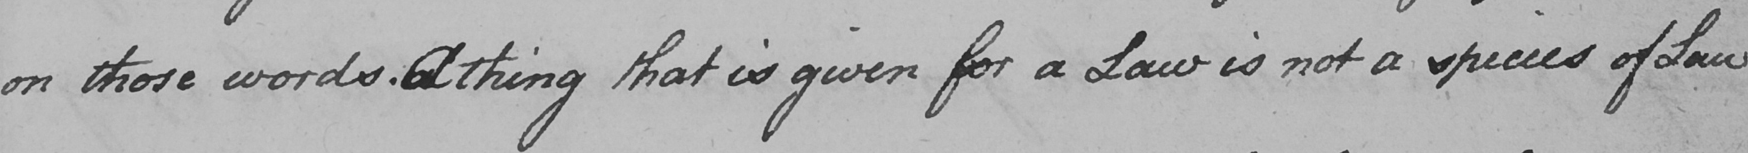Please transcribe the handwritten text in this image. on those words . A thing that is given for a Law is not a species of Law 